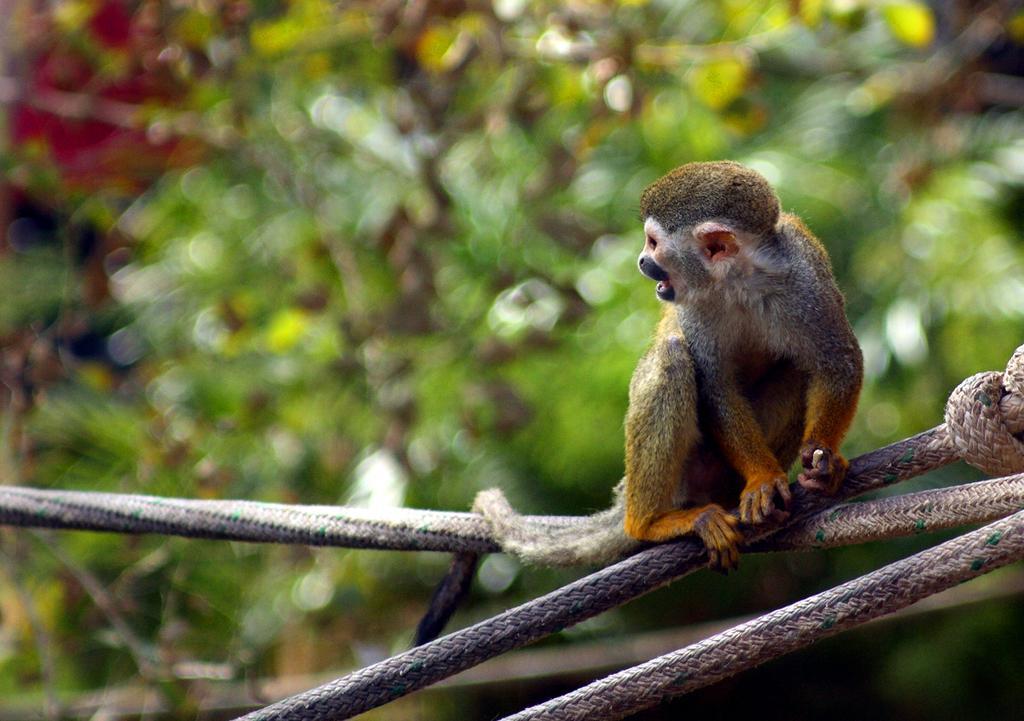Can you describe this image briefly? On the right side of the picture, we see an animal which looks like a monkey is sitting on the ropes. Behind that, we see trees and in the background, it is blurred. 